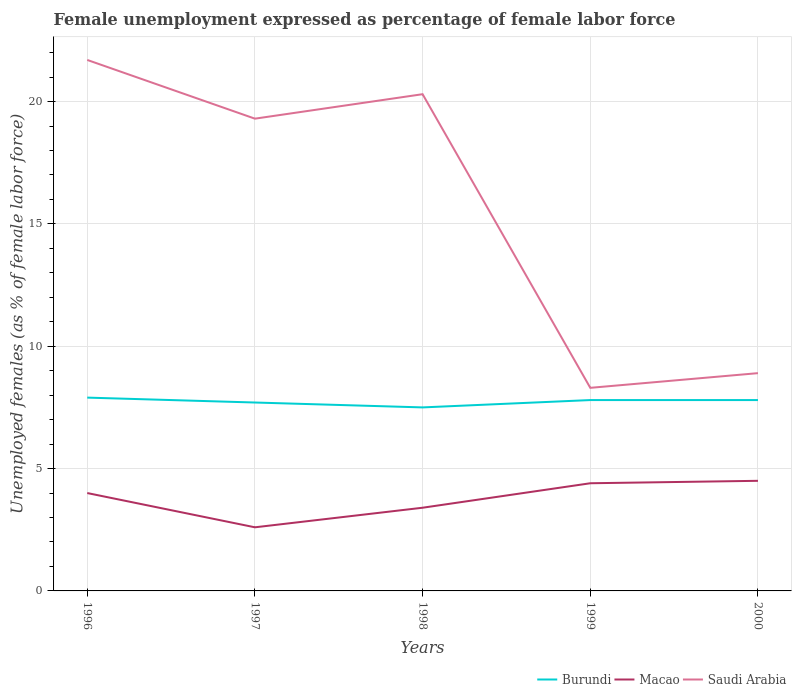How many different coloured lines are there?
Give a very brief answer. 3. Is the number of lines equal to the number of legend labels?
Give a very brief answer. Yes. Across all years, what is the maximum unemployment in females in in Saudi Arabia?
Your answer should be compact. 8.3. In which year was the unemployment in females in in Macao maximum?
Keep it short and to the point. 1997. What is the total unemployment in females in in Saudi Arabia in the graph?
Provide a succinct answer. 11.4. What is the difference between the highest and the second highest unemployment in females in in Macao?
Your answer should be compact. 1.9. What is the difference between the highest and the lowest unemployment in females in in Saudi Arabia?
Provide a short and direct response. 3. Is the unemployment in females in in Macao strictly greater than the unemployment in females in in Saudi Arabia over the years?
Provide a short and direct response. Yes. How many years are there in the graph?
Provide a succinct answer. 5. What is the difference between two consecutive major ticks on the Y-axis?
Make the answer very short. 5. Does the graph contain any zero values?
Ensure brevity in your answer.  No. Does the graph contain grids?
Offer a terse response. Yes. How many legend labels are there?
Keep it short and to the point. 3. What is the title of the graph?
Make the answer very short. Female unemployment expressed as percentage of female labor force. Does "Rwanda" appear as one of the legend labels in the graph?
Your response must be concise. No. What is the label or title of the Y-axis?
Offer a terse response. Unemployed females (as % of female labor force). What is the Unemployed females (as % of female labor force) in Burundi in 1996?
Give a very brief answer. 7.9. What is the Unemployed females (as % of female labor force) in Macao in 1996?
Keep it short and to the point. 4. What is the Unemployed females (as % of female labor force) in Saudi Arabia in 1996?
Ensure brevity in your answer.  21.7. What is the Unemployed females (as % of female labor force) in Burundi in 1997?
Offer a terse response. 7.7. What is the Unemployed females (as % of female labor force) of Macao in 1997?
Your answer should be compact. 2.6. What is the Unemployed females (as % of female labor force) in Saudi Arabia in 1997?
Provide a short and direct response. 19.3. What is the Unemployed females (as % of female labor force) of Burundi in 1998?
Your answer should be compact. 7.5. What is the Unemployed females (as % of female labor force) in Macao in 1998?
Your response must be concise. 3.4. What is the Unemployed females (as % of female labor force) of Saudi Arabia in 1998?
Give a very brief answer. 20.3. What is the Unemployed females (as % of female labor force) in Burundi in 1999?
Provide a succinct answer. 7.8. What is the Unemployed females (as % of female labor force) of Macao in 1999?
Offer a terse response. 4.4. What is the Unemployed females (as % of female labor force) of Saudi Arabia in 1999?
Your answer should be very brief. 8.3. What is the Unemployed females (as % of female labor force) in Burundi in 2000?
Keep it short and to the point. 7.8. What is the Unemployed females (as % of female labor force) of Saudi Arabia in 2000?
Your answer should be very brief. 8.9. Across all years, what is the maximum Unemployed females (as % of female labor force) in Burundi?
Provide a succinct answer. 7.9. Across all years, what is the maximum Unemployed females (as % of female labor force) of Saudi Arabia?
Provide a short and direct response. 21.7. Across all years, what is the minimum Unemployed females (as % of female labor force) in Burundi?
Offer a terse response. 7.5. Across all years, what is the minimum Unemployed females (as % of female labor force) in Macao?
Offer a very short reply. 2.6. Across all years, what is the minimum Unemployed females (as % of female labor force) in Saudi Arabia?
Make the answer very short. 8.3. What is the total Unemployed females (as % of female labor force) in Burundi in the graph?
Make the answer very short. 38.7. What is the total Unemployed females (as % of female labor force) in Saudi Arabia in the graph?
Keep it short and to the point. 78.5. What is the difference between the Unemployed females (as % of female labor force) in Burundi in 1996 and that in 1997?
Offer a very short reply. 0.2. What is the difference between the Unemployed females (as % of female labor force) of Macao in 1996 and that in 1997?
Your response must be concise. 1.4. What is the difference between the Unemployed females (as % of female labor force) of Macao in 1996 and that in 1998?
Give a very brief answer. 0.6. What is the difference between the Unemployed females (as % of female labor force) of Saudi Arabia in 1996 and that in 1998?
Your response must be concise. 1.4. What is the difference between the Unemployed females (as % of female labor force) in Burundi in 1996 and that in 1999?
Provide a short and direct response. 0.1. What is the difference between the Unemployed females (as % of female labor force) in Saudi Arabia in 1996 and that in 1999?
Offer a very short reply. 13.4. What is the difference between the Unemployed females (as % of female labor force) in Burundi in 1996 and that in 2000?
Keep it short and to the point. 0.1. What is the difference between the Unemployed females (as % of female labor force) in Saudi Arabia in 1996 and that in 2000?
Provide a short and direct response. 12.8. What is the difference between the Unemployed females (as % of female labor force) in Saudi Arabia in 1997 and that in 1998?
Make the answer very short. -1. What is the difference between the Unemployed females (as % of female labor force) of Burundi in 1997 and that in 1999?
Provide a short and direct response. -0.1. What is the difference between the Unemployed females (as % of female labor force) of Macao in 1997 and that in 1999?
Make the answer very short. -1.8. What is the difference between the Unemployed females (as % of female labor force) in Saudi Arabia in 1997 and that in 1999?
Provide a short and direct response. 11. What is the difference between the Unemployed females (as % of female labor force) in Burundi in 1997 and that in 2000?
Your answer should be compact. -0.1. What is the difference between the Unemployed females (as % of female labor force) of Macao in 1997 and that in 2000?
Provide a short and direct response. -1.9. What is the difference between the Unemployed females (as % of female labor force) in Saudi Arabia in 1997 and that in 2000?
Provide a succinct answer. 10.4. What is the difference between the Unemployed females (as % of female labor force) in Burundi in 1998 and that in 1999?
Keep it short and to the point. -0.3. What is the difference between the Unemployed females (as % of female labor force) of Macao in 1998 and that in 1999?
Keep it short and to the point. -1. What is the difference between the Unemployed females (as % of female labor force) in Burundi in 1998 and that in 2000?
Ensure brevity in your answer.  -0.3. What is the difference between the Unemployed females (as % of female labor force) of Macao in 1998 and that in 2000?
Your answer should be very brief. -1.1. What is the difference between the Unemployed females (as % of female labor force) of Saudi Arabia in 1998 and that in 2000?
Offer a terse response. 11.4. What is the difference between the Unemployed females (as % of female labor force) of Saudi Arabia in 1999 and that in 2000?
Provide a succinct answer. -0.6. What is the difference between the Unemployed females (as % of female labor force) in Burundi in 1996 and the Unemployed females (as % of female labor force) in Saudi Arabia in 1997?
Ensure brevity in your answer.  -11.4. What is the difference between the Unemployed females (as % of female labor force) of Macao in 1996 and the Unemployed females (as % of female labor force) of Saudi Arabia in 1997?
Your answer should be compact. -15.3. What is the difference between the Unemployed females (as % of female labor force) in Burundi in 1996 and the Unemployed females (as % of female labor force) in Macao in 1998?
Give a very brief answer. 4.5. What is the difference between the Unemployed females (as % of female labor force) of Burundi in 1996 and the Unemployed females (as % of female labor force) of Saudi Arabia in 1998?
Your answer should be very brief. -12.4. What is the difference between the Unemployed females (as % of female labor force) in Macao in 1996 and the Unemployed females (as % of female labor force) in Saudi Arabia in 1998?
Provide a succinct answer. -16.3. What is the difference between the Unemployed females (as % of female labor force) of Burundi in 1996 and the Unemployed females (as % of female labor force) of Saudi Arabia in 1999?
Keep it short and to the point. -0.4. What is the difference between the Unemployed females (as % of female labor force) of Burundi in 1996 and the Unemployed females (as % of female labor force) of Macao in 2000?
Your answer should be very brief. 3.4. What is the difference between the Unemployed females (as % of female labor force) of Macao in 1996 and the Unemployed females (as % of female labor force) of Saudi Arabia in 2000?
Provide a short and direct response. -4.9. What is the difference between the Unemployed females (as % of female labor force) of Burundi in 1997 and the Unemployed females (as % of female labor force) of Macao in 1998?
Ensure brevity in your answer.  4.3. What is the difference between the Unemployed females (as % of female labor force) of Macao in 1997 and the Unemployed females (as % of female labor force) of Saudi Arabia in 1998?
Your answer should be very brief. -17.7. What is the difference between the Unemployed females (as % of female labor force) in Burundi in 1997 and the Unemployed females (as % of female labor force) in Macao in 1999?
Provide a succinct answer. 3.3. What is the difference between the Unemployed females (as % of female labor force) of Burundi in 1997 and the Unemployed females (as % of female labor force) of Saudi Arabia in 1999?
Your answer should be compact. -0.6. What is the difference between the Unemployed females (as % of female labor force) of Burundi in 1997 and the Unemployed females (as % of female labor force) of Macao in 2000?
Provide a short and direct response. 3.2. What is the difference between the Unemployed females (as % of female labor force) in Burundi in 1998 and the Unemployed females (as % of female labor force) in Saudi Arabia in 1999?
Your answer should be very brief. -0.8. What is the difference between the Unemployed females (as % of female labor force) of Burundi in 1998 and the Unemployed females (as % of female labor force) of Macao in 2000?
Make the answer very short. 3. What is the difference between the Unemployed females (as % of female labor force) of Burundi in 1998 and the Unemployed females (as % of female labor force) of Saudi Arabia in 2000?
Keep it short and to the point. -1.4. What is the difference between the Unemployed females (as % of female labor force) in Macao in 1998 and the Unemployed females (as % of female labor force) in Saudi Arabia in 2000?
Provide a succinct answer. -5.5. What is the difference between the Unemployed females (as % of female labor force) in Burundi in 1999 and the Unemployed females (as % of female labor force) in Saudi Arabia in 2000?
Give a very brief answer. -1.1. What is the difference between the Unemployed females (as % of female labor force) in Macao in 1999 and the Unemployed females (as % of female labor force) in Saudi Arabia in 2000?
Your answer should be very brief. -4.5. What is the average Unemployed females (as % of female labor force) of Burundi per year?
Provide a short and direct response. 7.74. What is the average Unemployed females (as % of female labor force) in Macao per year?
Provide a short and direct response. 3.78. In the year 1996, what is the difference between the Unemployed females (as % of female labor force) of Burundi and Unemployed females (as % of female labor force) of Macao?
Keep it short and to the point. 3.9. In the year 1996, what is the difference between the Unemployed females (as % of female labor force) in Burundi and Unemployed females (as % of female labor force) in Saudi Arabia?
Make the answer very short. -13.8. In the year 1996, what is the difference between the Unemployed females (as % of female labor force) of Macao and Unemployed females (as % of female labor force) of Saudi Arabia?
Give a very brief answer. -17.7. In the year 1997, what is the difference between the Unemployed females (as % of female labor force) in Burundi and Unemployed females (as % of female labor force) in Macao?
Give a very brief answer. 5.1. In the year 1997, what is the difference between the Unemployed females (as % of female labor force) in Macao and Unemployed females (as % of female labor force) in Saudi Arabia?
Offer a very short reply. -16.7. In the year 1998, what is the difference between the Unemployed females (as % of female labor force) in Burundi and Unemployed females (as % of female labor force) in Saudi Arabia?
Give a very brief answer. -12.8. In the year 1998, what is the difference between the Unemployed females (as % of female labor force) in Macao and Unemployed females (as % of female labor force) in Saudi Arabia?
Ensure brevity in your answer.  -16.9. In the year 1999, what is the difference between the Unemployed females (as % of female labor force) in Burundi and Unemployed females (as % of female labor force) in Saudi Arabia?
Your answer should be compact. -0.5. In the year 1999, what is the difference between the Unemployed females (as % of female labor force) in Macao and Unemployed females (as % of female labor force) in Saudi Arabia?
Make the answer very short. -3.9. What is the ratio of the Unemployed females (as % of female labor force) of Burundi in 1996 to that in 1997?
Provide a short and direct response. 1.03. What is the ratio of the Unemployed females (as % of female labor force) of Macao in 1996 to that in 1997?
Offer a terse response. 1.54. What is the ratio of the Unemployed females (as % of female labor force) in Saudi Arabia in 1996 to that in 1997?
Your response must be concise. 1.12. What is the ratio of the Unemployed females (as % of female labor force) in Burundi in 1996 to that in 1998?
Keep it short and to the point. 1.05. What is the ratio of the Unemployed females (as % of female labor force) in Macao in 1996 to that in 1998?
Provide a short and direct response. 1.18. What is the ratio of the Unemployed females (as % of female labor force) of Saudi Arabia in 1996 to that in 1998?
Offer a very short reply. 1.07. What is the ratio of the Unemployed females (as % of female labor force) of Burundi in 1996 to that in 1999?
Provide a short and direct response. 1.01. What is the ratio of the Unemployed females (as % of female labor force) in Saudi Arabia in 1996 to that in 1999?
Your answer should be very brief. 2.61. What is the ratio of the Unemployed females (as % of female labor force) of Burundi in 1996 to that in 2000?
Provide a succinct answer. 1.01. What is the ratio of the Unemployed females (as % of female labor force) in Macao in 1996 to that in 2000?
Provide a short and direct response. 0.89. What is the ratio of the Unemployed females (as % of female labor force) of Saudi Arabia in 1996 to that in 2000?
Provide a short and direct response. 2.44. What is the ratio of the Unemployed females (as % of female labor force) in Burundi in 1997 to that in 1998?
Make the answer very short. 1.03. What is the ratio of the Unemployed females (as % of female labor force) of Macao in 1997 to that in 1998?
Keep it short and to the point. 0.76. What is the ratio of the Unemployed females (as % of female labor force) of Saudi Arabia in 1997 to that in 1998?
Your answer should be compact. 0.95. What is the ratio of the Unemployed females (as % of female labor force) of Burundi in 1997 to that in 1999?
Offer a terse response. 0.99. What is the ratio of the Unemployed females (as % of female labor force) of Macao in 1997 to that in 1999?
Ensure brevity in your answer.  0.59. What is the ratio of the Unemployed females (as % of female labor force) in Saudi Arabia in 1997 to that in 1999?
Offer a very short reply. 2.33. What is the ratio of the Unemployed females (as % of female labor force) in Burundi in 1997 to that in 2000?
Provide a succinct answer. 0.99. What is the ratio of the Unemployed females (as % of female labor force) in Macao in 1997 to that in 2000?
Offer a terse response. 0.58. What is the ratio of the Unemployed females (as % of female labor force) in Saudi Arabia in 1997 to that in 2000?
Give a very brief answer. 2.17. What is the ratio of the Unemployed females (as % of female labor force) in Burundi in 1998 to that in 1999?
Your response must be concise. 0.96. What is the ratio of the Unemployed females (as % of female labor force) of Macao in 1998 to that in 1999?
Your answer should be very brief. 0.77. What is the ratio of the Unemployed females (as % of female labor force) of Saudi Arabia in 1998 to that in 1999?
Your response must be concise. 2.45. What is the ratio of the Unemployed females (as % of female labor force) of Burundi in 1998 to that in 2000?
Give a very brief answer. 0.96. What is the ratio of the Unemployed females (as % of female labor force) in Macao in 1998 to that in 2000?
Make the answer very short. 0.76. What is the ratio of the Unemployed females (as % of female labor force) in Saudi Arabia in 1998 to that in 2000?
Your answer should be very brief. 2.28. What is the ratio of the Unemployed females (as % of female labor force) in Burundi in 1999 to that in 2000?
Your answer should be compact. 1. What is the ratio of the Unemployed females (as % of female labor force) of Macao in 1999 to that in 2000?
Offer a terse response. 0.98. What is the ratio of the Unemployed females (as % of female labor force) of Saudi Arabia in 1999 to that in 2000?
Your answer should be very brief. 0.93. What is the difference between the highest and the second highest Unemployed females (as % of female labor force) of Macao?
Provide a succinct answer. 0.1. What is the difference between the highest and the lowest Unemployed females (as % of female labor force) in Burundi?
Offer a terse response. 0.4. 